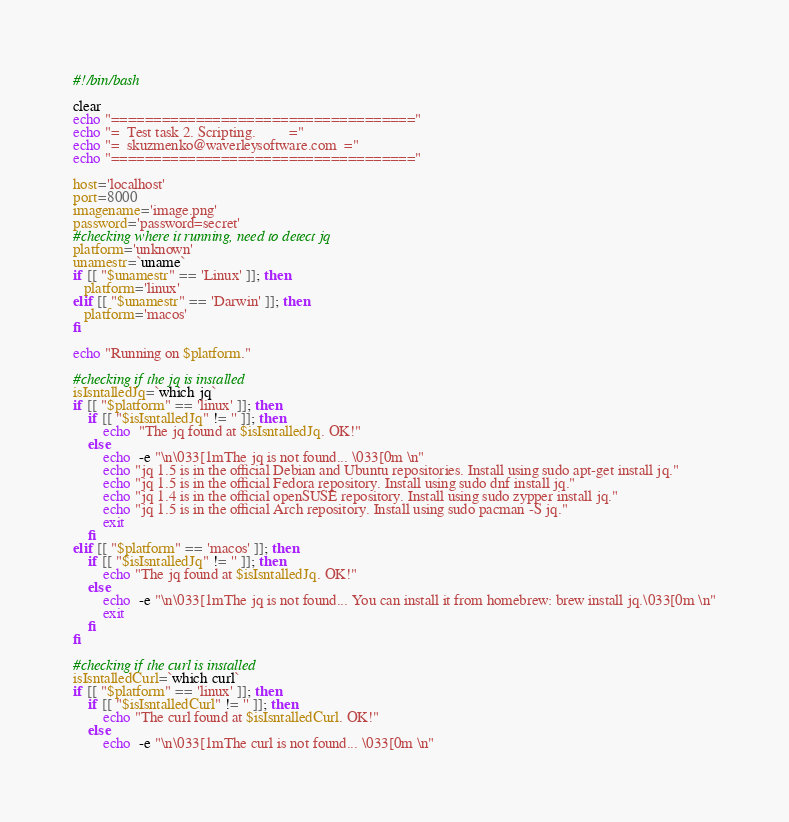<code> <loc_0><loc_0><loc_500><loc_500><_Bash_>#!/bin/bash

clear
echo "===================================="
echo "=  Test task 2. Scripting.         ="
echo "=  skuzmenko@waverleysoftware.com  ="
echo "===================================="

host='localhost'
port=8000
imagename='image.png'
password='password=secret'
#checking where it running, need to detect jq
platform='unknown'
unamestr=`uname`
if [[ "$unamestr" == 'Linux' ]]; then
   platform='linux'
elif [[ "$unamestr" == 'Darwin' ]]; then
   platform='macos'
fi

echo "Running on $platform."

#checking if the jq is installed
isIsntalledJq=`which jq`
if [[ "$platform" == 'linux' ]]; then
    if [[ "$isIsntalledJq" != '' ]]; then
        echo  "The jq found at $isIsntalledJq. OK!"
    else
        echo  -e "\n\033[1mThe jq is not found... \033[0m \n"
        echo "jq 1.5 is in the official Debian and Ubuntu repositories. Install using sudo apt-get install jq."
        echo "jq 1.5 is in the official Fedora repository. Install using sudo dnf install jq."
        echo "jq 1.4 is in the official openSUSE repository. Install using sudo zypper install jq."
        echo "jq 1.5 is in the official Arch repository. Install using sudo pacman -S jq."
        exit
    fi
elif [[ "$platform" == 'macos' ]]; then
    if [[ "$isIsntalledJq" != '' ]]; then
        echo "The jq found at $isIsntalledJq. OK!"
    else
        echo  -e "\n\033[1mThe jq is not found... You can install it from homebrew: brew install jq.\033[0m \n"
        exit
    fi
fi

#checking if the curl is installed
isIsntalledCurl=`which curl`
if [[ "$platform" == 'linux' ]]; then
    if [[ "$isIsntalledCurl" != '' ]]; then
        echo "The curl found at $isIsntalledCurl. OK!"
    else
        echo  -e "\n\033[1mThe curl is not found... \033[0m \n"</code> 